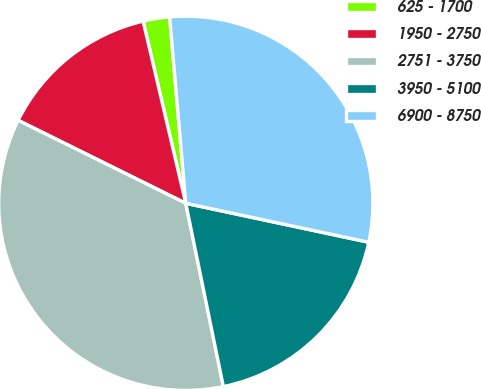Convert chart. <chart><loc_0><loc_0><loc_500><loc_500><pie_chart><fcel>625 - 1700<fcel>1950 - 2750<fcel>2751 - 3750<fcel>3950 - 5100<fcel>6900 - 8750<nl><fcel>2.29%<fcel>14.02%<fcel>35.53%<fcel>18.44%<fcel>29.71%<nl></chart> 